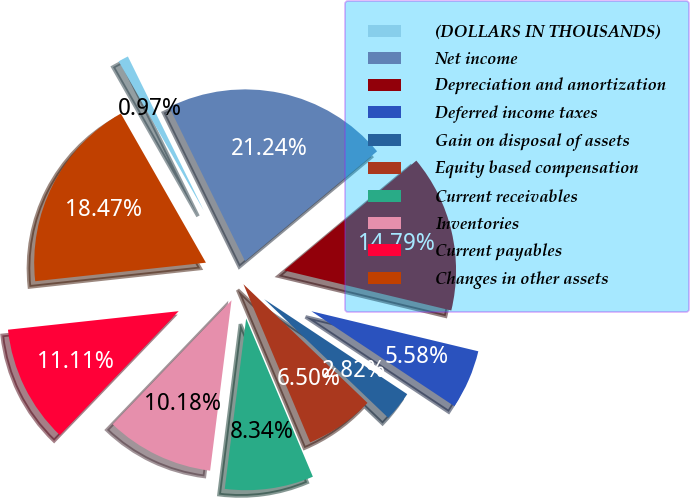Convert chart to OTSL. <chart><loc_0><loc_0><loc_500><loc_500><pie_chart><fcel>(DOLLARS IN THOUSANDS)<fcel>Net income<fcel>Depreciation and amortization<fcel>Deferred income taxes<fcel>Gain on disposal of assets<fcel>Equity based compensation<fcel>Current receivables<fcel>Inventories<fcel>Current payables<fcel>Changes in other assets<nl><fcel>0.97%<fcel>21.24%<fcel>14.79%<fcel>5.58%<fcel>2.82%<fcel>6.5%<fcel>8.34%<fcel>10.18%<fcel>11.11%<fcel>18.47%<nl></chart> 